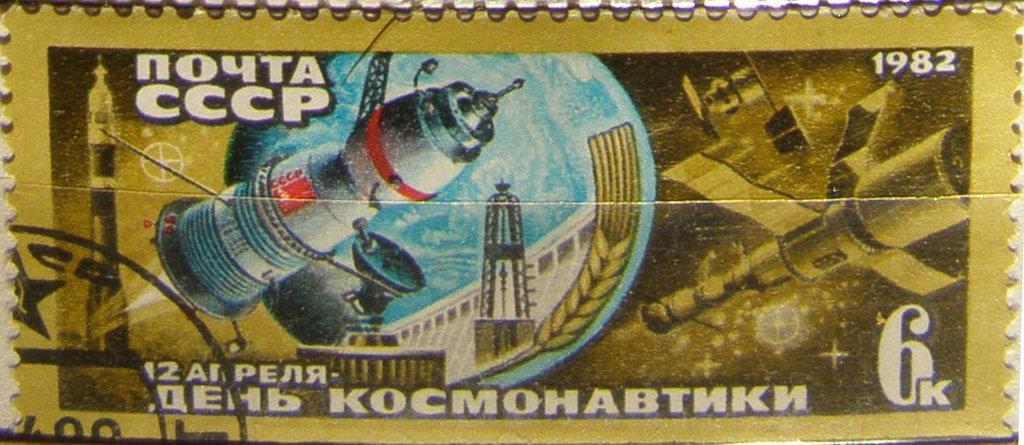Please provide a concise description of this image. In this picture we can see a stamp. On this stamp we can see rockets, dish antenna, tower, building, satellites, numbers and some text. 